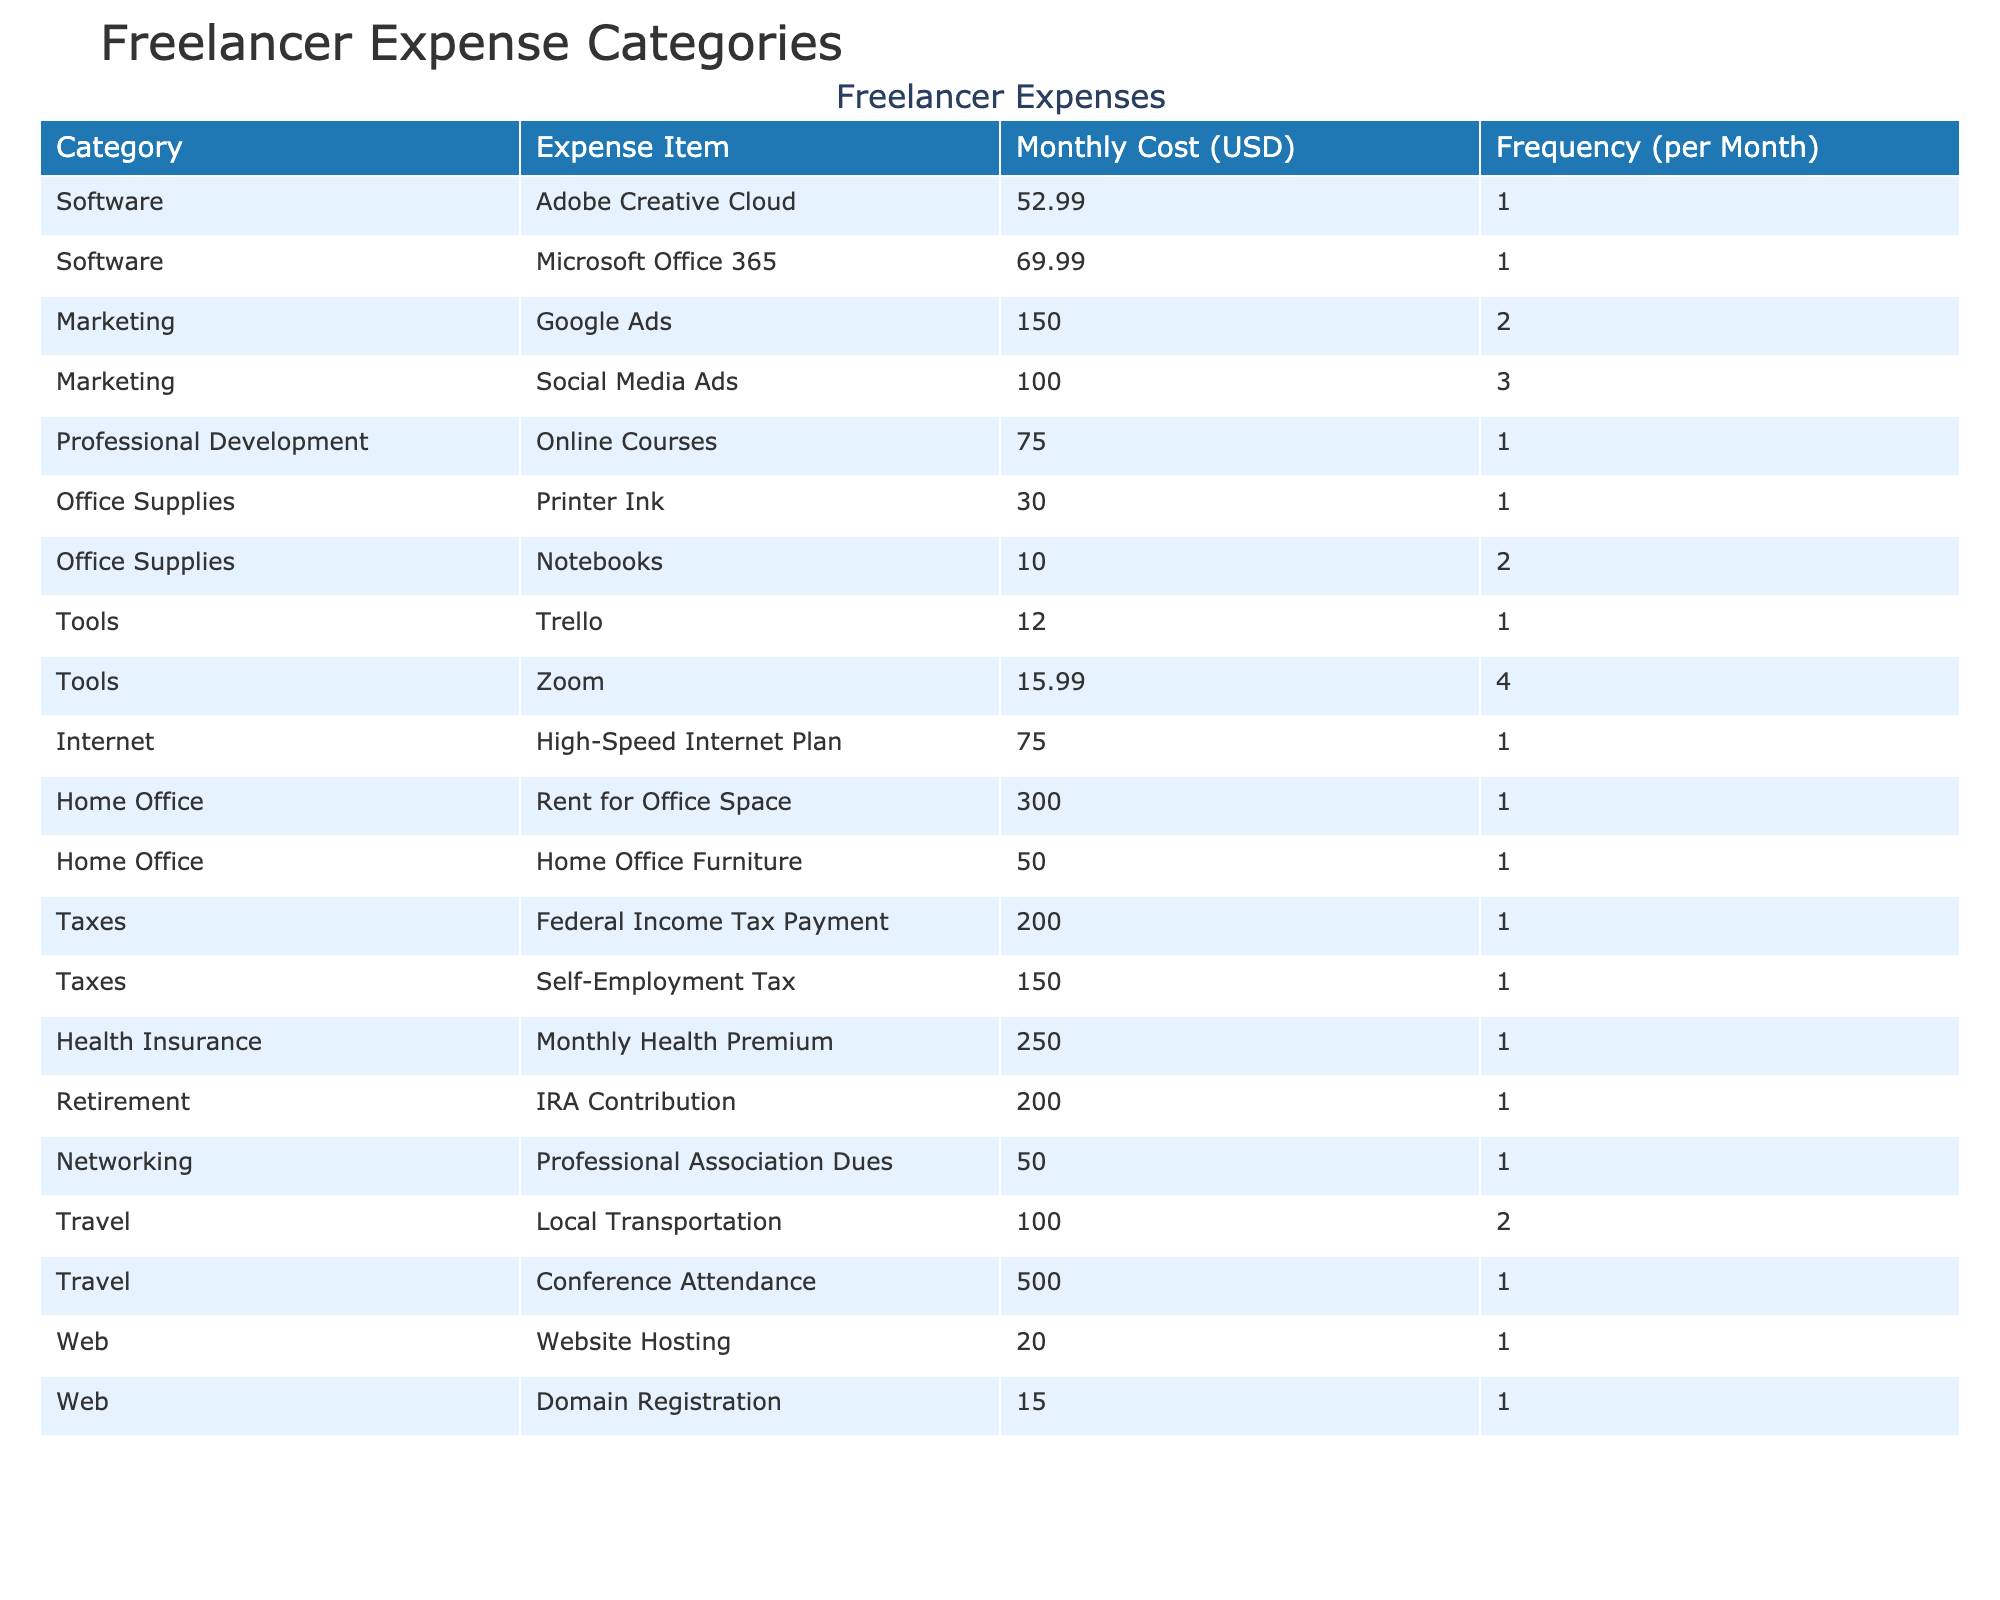What is the average monthly cost of Zoom? In the table, under the "Tools" category, the average monthly cost for Zoom is listed as 15.99 USD.
Answer: 15.99 USD How many times per month is Adobe Creative Cloud purchased? The frequency of purchase for Adobe Creative Cloud, listed under the "Software" category, is 1 time per month.
Answer: 1 time What is the total monthly cost for travel-related expenses? The travel-related expenses are Local Transportation (100.00 USD, 2 times) and Conference Attendance (500.00 USD, 1 time). The total is calculated as 100 + 500 = 600.
Answer: 600 USD Is the cost of Microsoft Office 365 higher than that of Adobe Creative Cloud? The cost of Microsoft Office 365 is 69.99 USD, while Adobe Creative Cloud is 52.99 USD. Since 69.99 is greater than 52.99, the statement is true.
Answer: Yes What is the average cost of all software expenses? The software expenses are Adobe Creative Cloud (52.99 USD) and Microsoft Office 365 (69.99 USD). The average is calculated as (52.99 + 69.99) / 2 = 61.99 USD.
Answer: 61.99 USD How many expenses have a frequency of purchase greater than 2 times per month? The table shows only Zoom (4 times) and Social Media Ads (3 times) with a frequency greater than 2. That means there are 2 such expenses.
Answer: 2 What is the total average monthly cost for health insurance and retirement contributions combined? The average monthly cost for health insurance is 250.00 USD, and for IRA contributions, it is 200.00 USD. Adding these gives 250 + 200 = 450.
Answer: 450 USD Which expense category has the highest individual expense? The highest individual expense in the table is Conference Attendance under the "Travel" category, which amounts to 500.00 USD.
Answer: Travel What is the difference in average monthly cost between the highest and lowest expense categories? The highest expense is Rent for Office Space (300.00 USD) and the lowest is Notebooks (10.00 USD). The difference is calculated as 300 - 10 = 290.
Answer: 290 USD Are there any expenses listed in the "Web" category that are above 20 USD? The expenses in the "Web" category are Website Hosting (20.00 USD) and Domain Registration (15.00 USD). Only Website Hosting meets the criteria, thus the answer is false.
Answer: No 